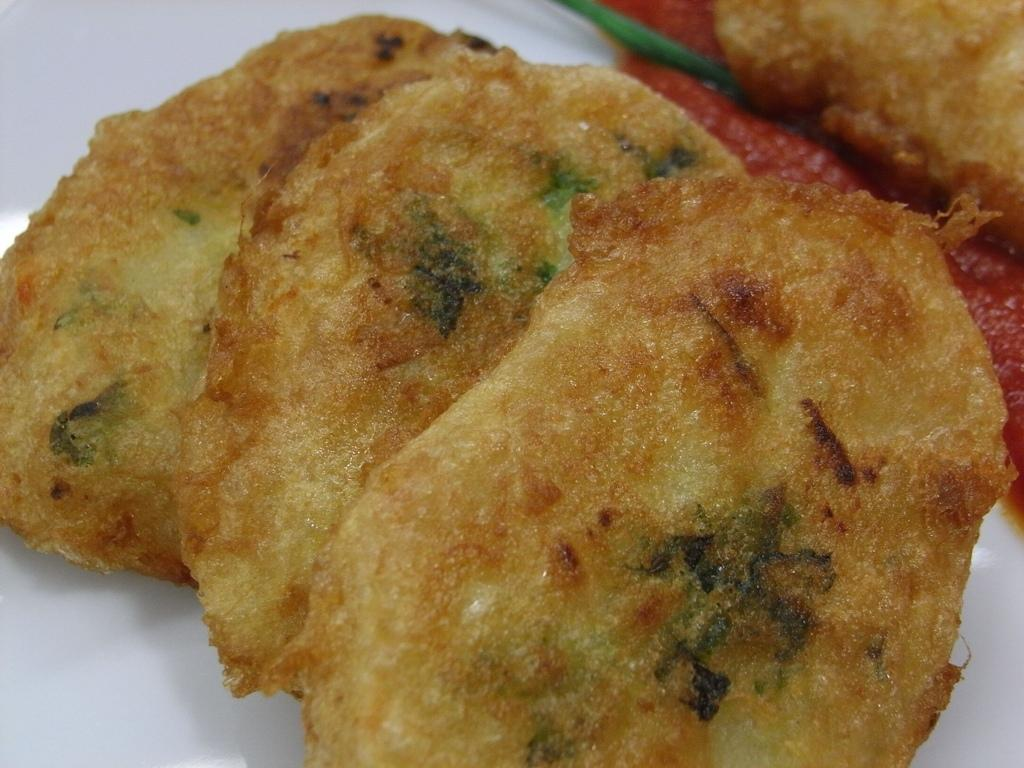What type of food is visible in the image? There is food in the image, and it appears to be sauce. Can you describe the sauce in more detail? Unfortunately, the image does not provide enough detail to describe the sauce further. How many robins are sitting on the sack in the image? There is no sack or robin present in the image. What type of sidewalk is visible in the image? There is no sidewalk visible in the image. 